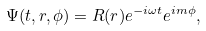<formula> <loc_0><loc_0><loc_500><loc_500>\Psi ( t , r , \phi ) = R ( r ) e ^ { - i \omega t } e ^ { i m \phi } ,</formula> 